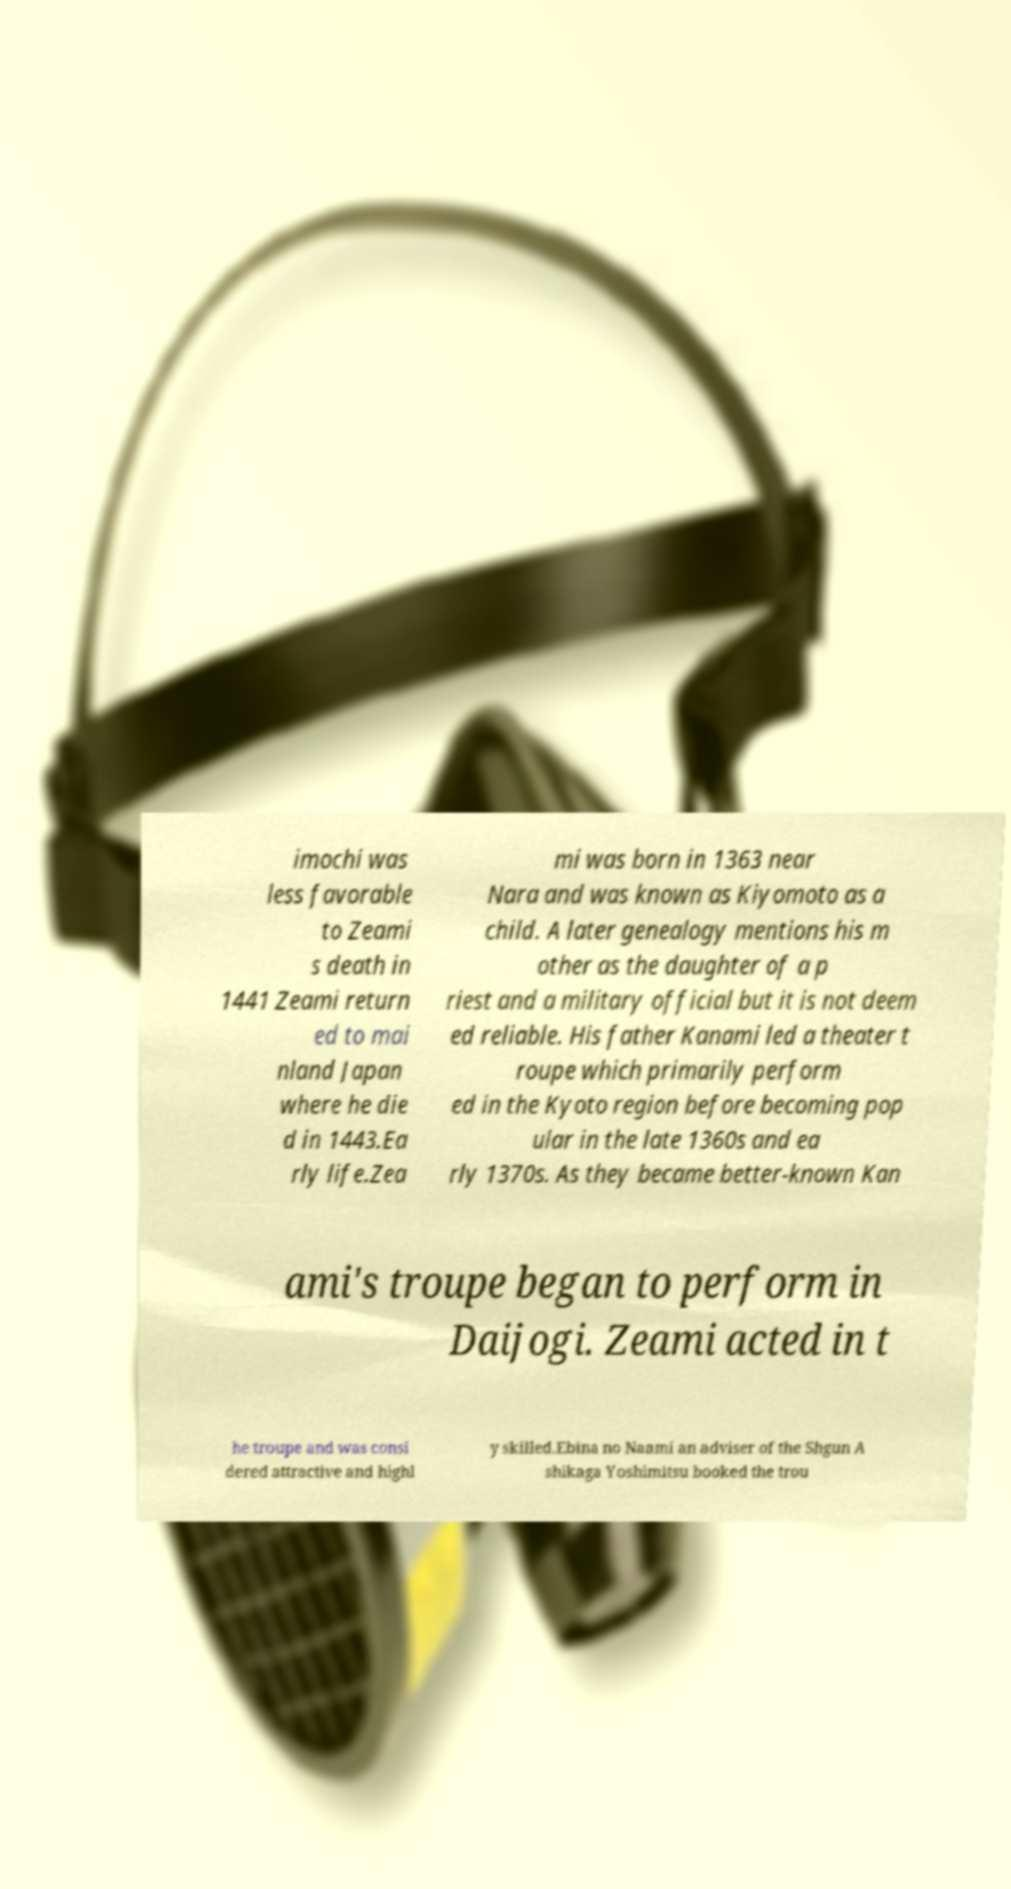Can you read and provide the text displayed in the image?This photo seems to have some interesting text. Can you extract and type it out for me? imochi was less favorable to Zeami s death in 1441 Zeami return ed to mai nland Japan where he die d in 1443.Ea rly life.Zea mi was born in 1363 near Nara and was known as Kiyomoto as a child. A later genealogy mentions his m other as the daughter of a p riest and a military official but it is not deem ed reliable. His father Kanami led a theater t roupe which primarily perform ed in the Kyoto region before becoming pop ular in the late 1360s and ea rly 1370s. As they became better-known Kan ami's troupe began to perform in Daijogi. Zeami acted in t he troupe and was consi dered attractive and highl y skilled.Ebina no Naami an adviser of the Shgun A shikaga Yoshimitsu booked the trou 